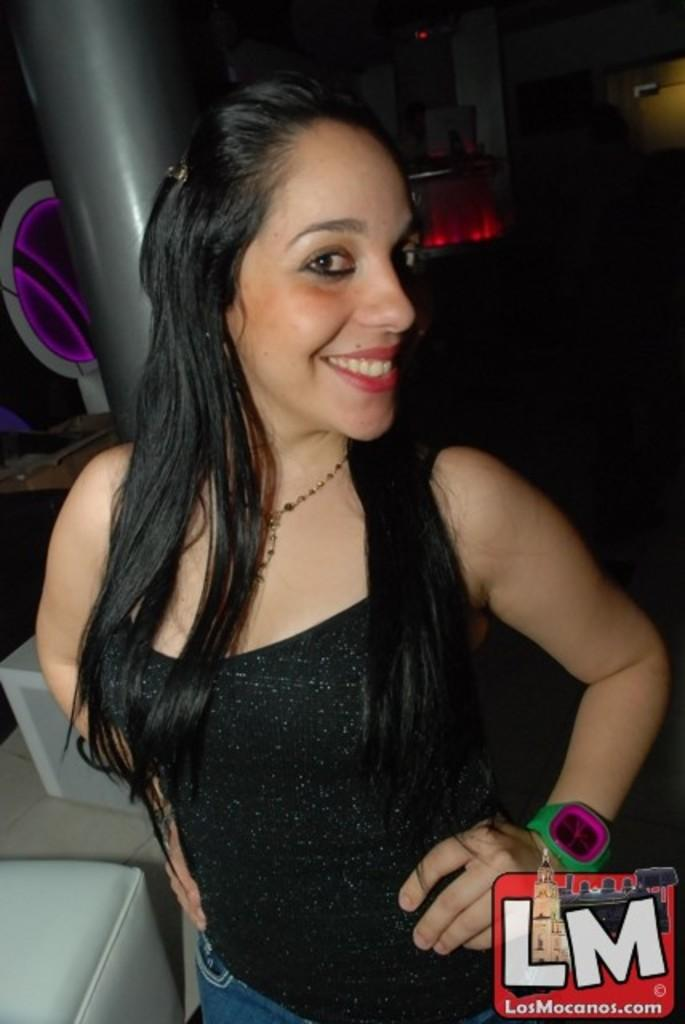What is the person in the image wearing? The person in the image is wearing a black and blue dress. What type of furniture is in the image? There is an ash-colored couch in the image. What object can be seen in the image that is typically used for support or balance? There is a pole in the image. What is the purpose of the board in the image? The purpose of the board in the image is not specified, but it could be used for various activities or as a decorative element. What colors are predominant in the background of the image? The background of the image has a red and black color scheme. Can you see a snake slithering on the couch in the image? No, there is no snake present in the image. What is the person's elbow doing in the image? There is no specific mention of the person's elbow in the image, so it cannot be determined what it is doing. 